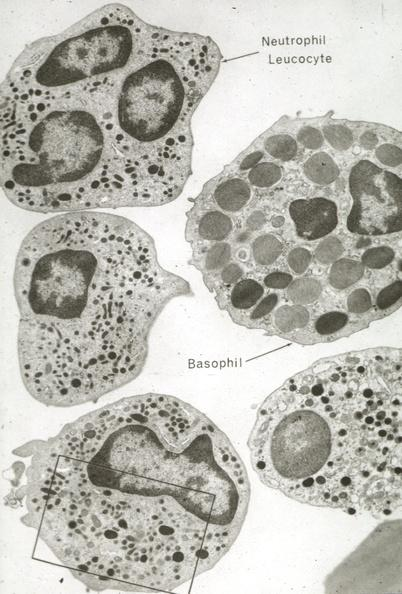s atherosclerosis present?
Answer the question using a single word or phrase. No 